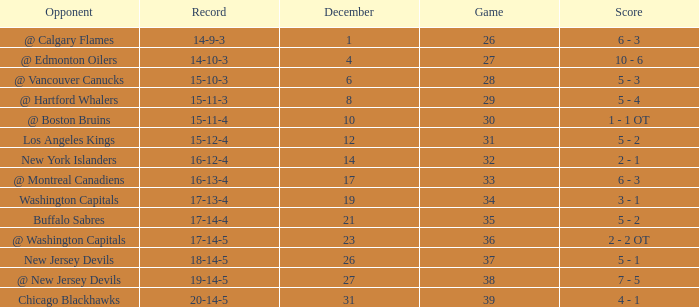Game larger than 34, and a December smaller than 23 had what record? 17-14-4. 